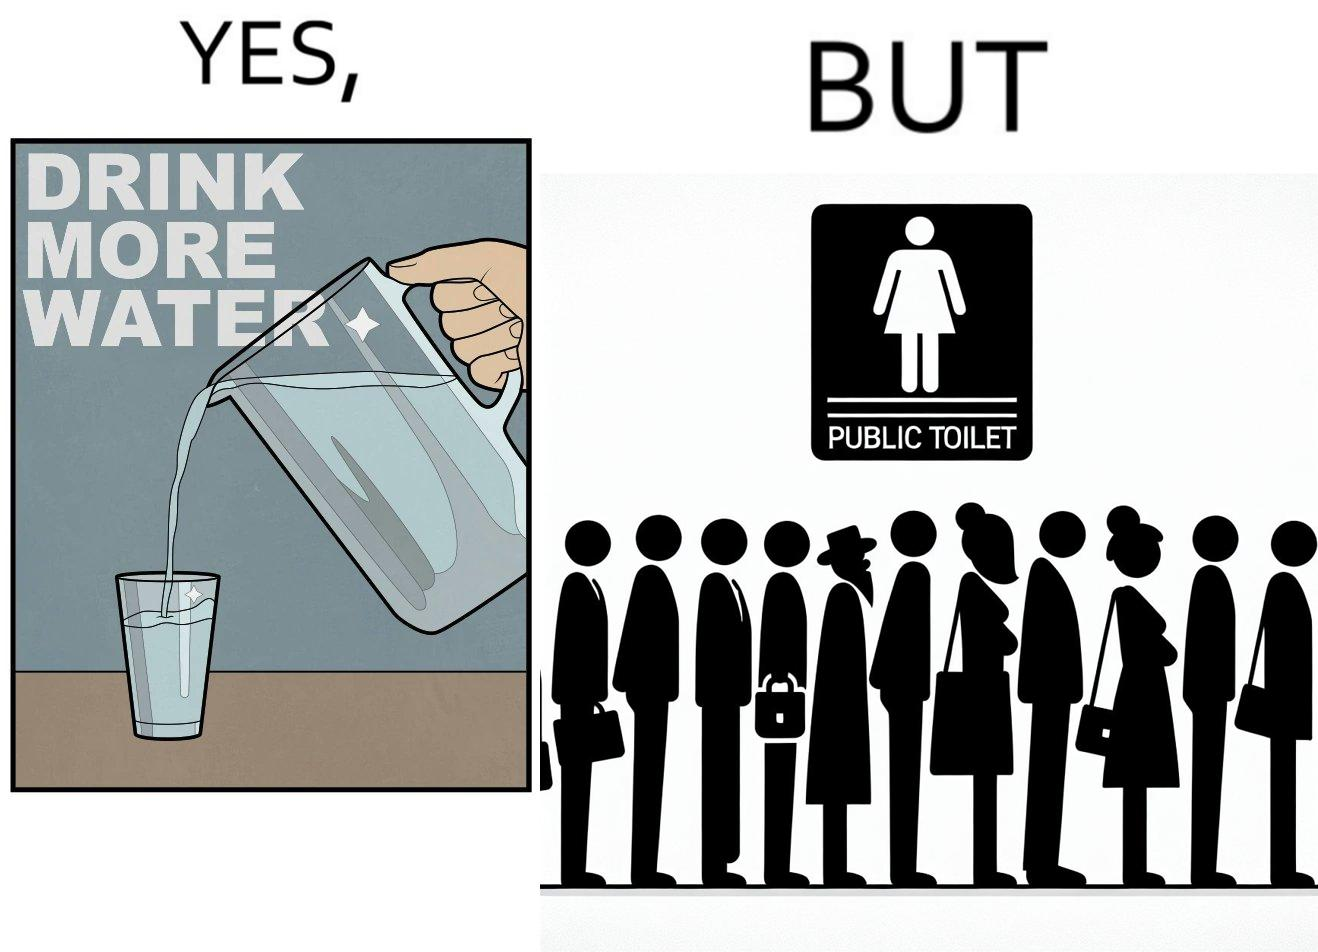Explain the humor or irony in this image. The image is ironical, as the message "Drink more water" is meant to improve health, but in turn, it would lead to longer queues in front of public toilets, leading to people holding urine for longer periods, in turn leading to deterioration in health. 